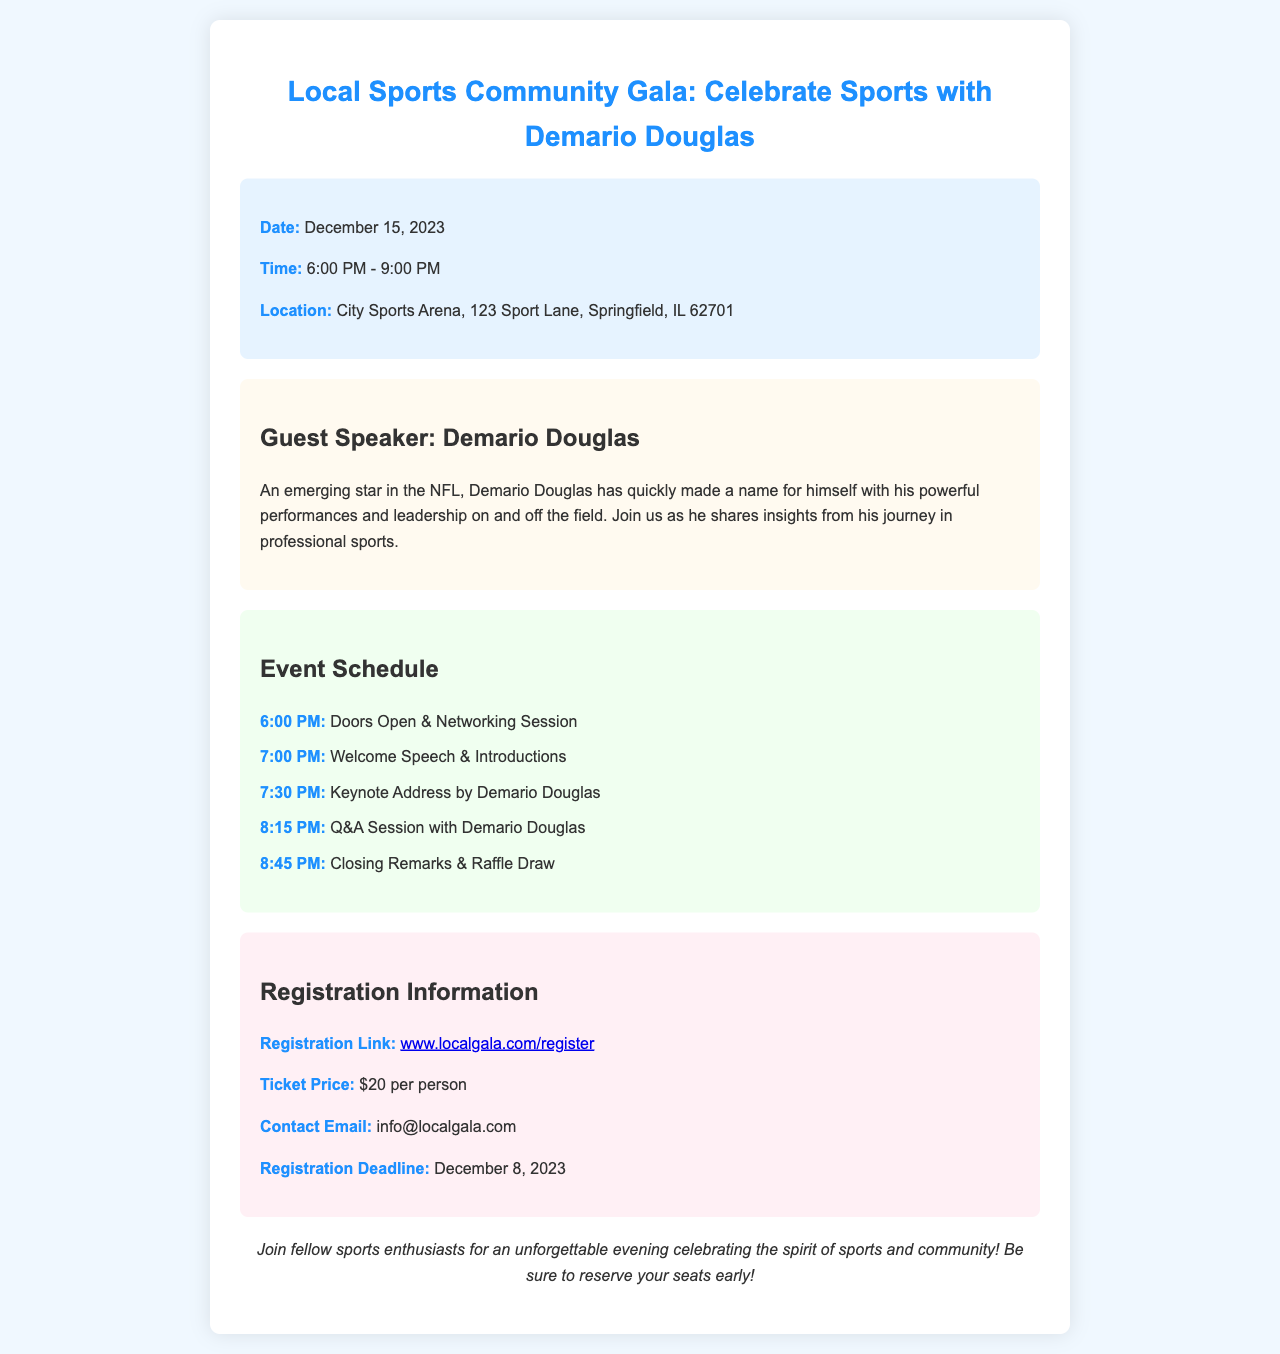what is the date of the event? The date of the event is specified in the event details section of the document.
Answer: December 15, 2023 what time does the event start? The start time is provided in the event details section.
Answer: 6:00 PM where is the event taking place? The location of the event is mentioned in the event details section.
Answer: City Sports Arena, 123 Sport Lane, Springfield, IL 62701 who is the guest speaker? The document clearly states the guest speaker's name in the guest speaker section.
Answer: Demario Douglas what is the ticket price for the event? The ticket price is outlined in the registration information section of the document.
Answer: $20 per person when is the registration deadline? The deadline for registration is mentioned in the registration information section.
Answer: December 8, 2023 what is the first activity scheduled for the event? The first activity is detailed in the event schedule section.
Answer: Doors Open & Networking Session how long is the keynote address expected to last? The timing of the keynote address is provided in the event schedule, indicating how long it will last before the next activity.
Answer: 45 minutes what type of event is this document inviting attendees to? The theme of the event is described in the title and throughout the document, categorizing it as a celebratory gathering.
Answer: Sports Community Gala 